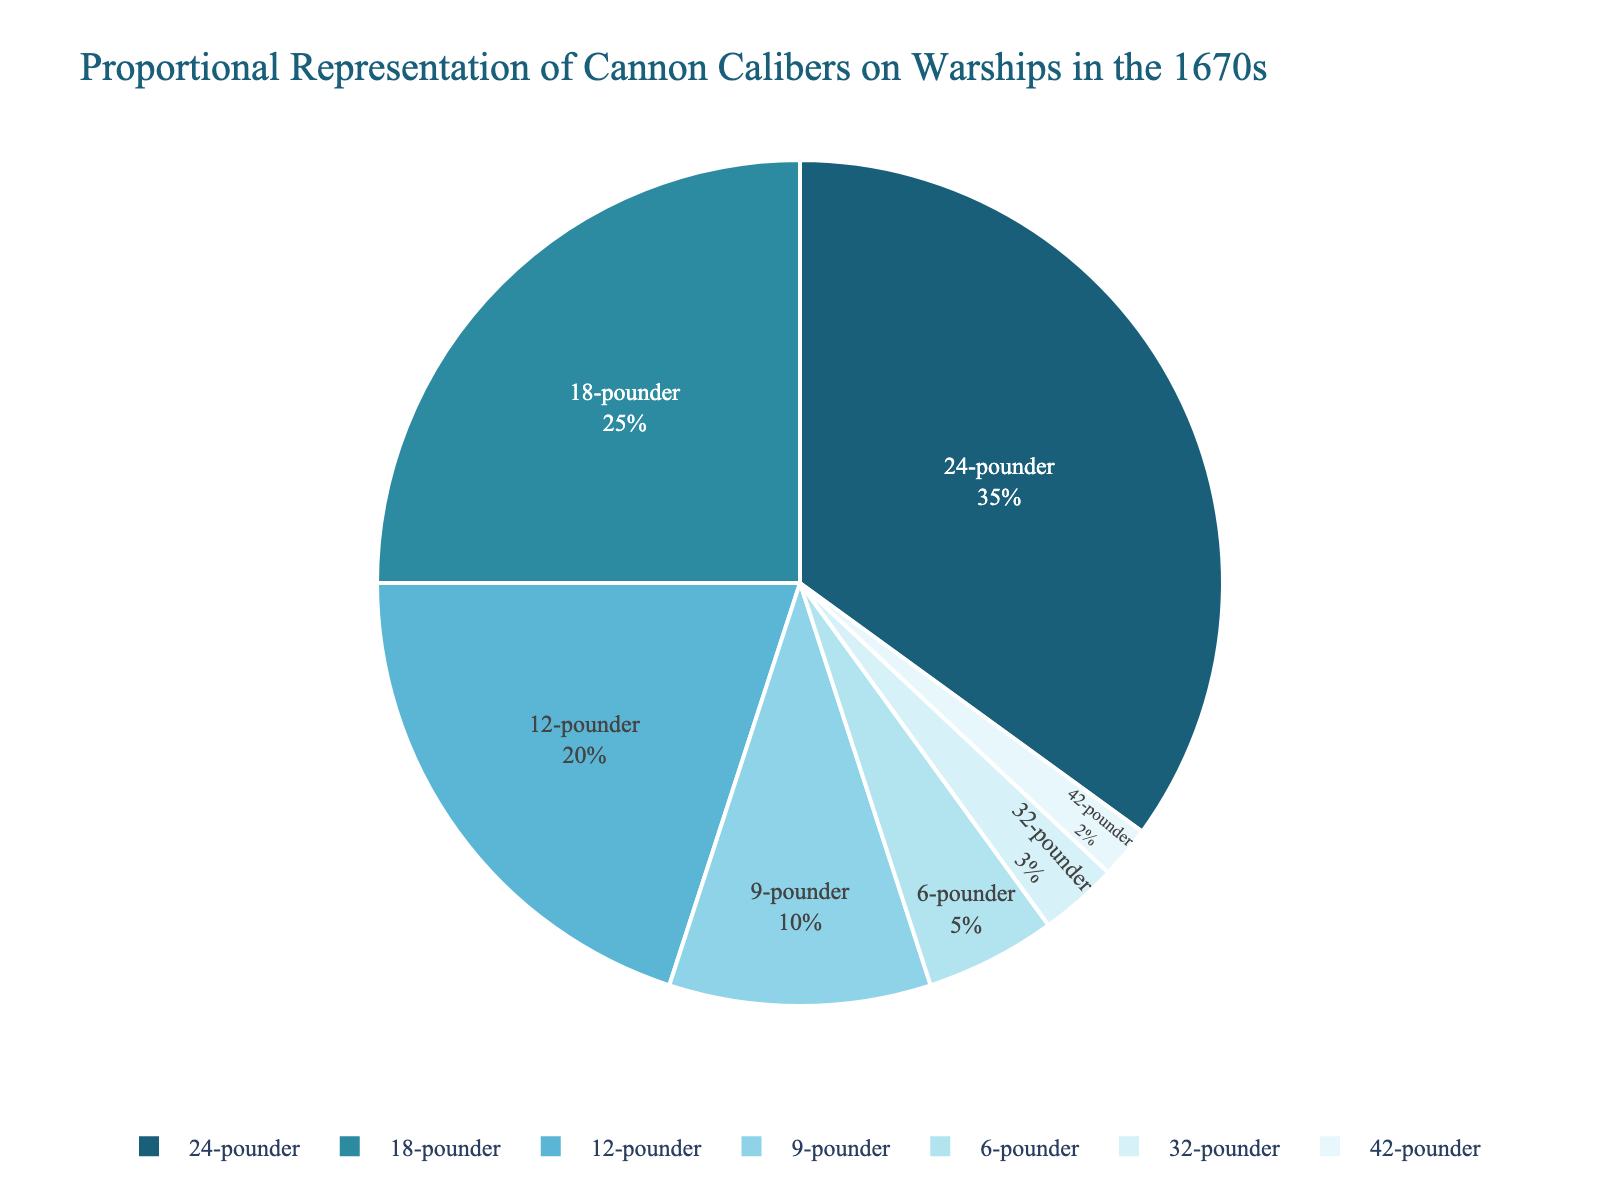What is the sum percentage of 24-pounders, 18-pounders, and 12-pounders? First, find the percentages for 24-pounders (35%), 18-pounders (25%), and 12-pounders (20%). Then, add them together: 35 + 25 + 20 = 80.
Answer: 80% Which cannon caliber has the highest representation on the warships? Compare the percentages for all cannon calibers. The highest percentage is 35% for the 24-pounder.
Answer: 24-pounder How much more prevalent are 18-pounders than 6-pounders? Find the percentages for both: 18-pounders (25%) and 6-pounders (5%). Subtract the lower percentage from the higher one: 25 - 5 = 20.
Answer: 20% Are there more 32-pounders, 42-pounders, or 6-pounders on these warships? Compare the percentages: 32-pounders (3%), 42-pounders (2%), and 6-pounders (5%). The highest percentage is 6% for the 6-pounders.
Answer: 6-pounders What is the combined percentage of the cannons smaller than 12-pounders? Add the percentages of 9-pounders (10%), 6-pounders (5%), 32-pounders (3%), and 42-pounders (2%) together: 10 + 5 + 3 + 2 = 20.
Answer: 20% Which two cannon calibers have the closest representation percentages? Compare the percentages: 24-pounder (35%), 18-pounder (25%), 12-pounder (20%), 9-pounder (10%), 6-pounder (5%), 32-pounder (3%), 42-pounder (2%). The closest are 32-pounder (3%) and 42-pounder (2%), with a difference of only 1%.
Answer: 32-pounder and 42-pounder How many calibers have a representation greater than 10%? Identify calibers with percentages above 10%: 24-pounder (35%), 18-pounder (25%), and 12-pounder (20%). There are 3 calibers.
Answer: 3 What is the difference in representation between 24-pounders and the sum of 9-pounders and 32-pounders? Calculate the sum of 9-pounders (10%) and 32-pounders (3%): 10 + 3 = 13. Then subtract this sum from 24-pounders (35%): 35 - 13 = 22.
Answer: 22% What proportion of the cannons are 9-pounders compared to 12-pounders? Find the percentages for 9-pounders (10%) and 12-pounders (20%). The ratio is 10/20, which simplifies to 1:2.
Answer: 1:2 